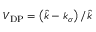<formula> <loc_0><loc_0><loc_500><loc_500>V _ { D P } = \left ( \hat { k } - k _ { \sigma } \right ) / \hat { k }</formula> 